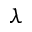<formula> <loc_0><loc_0><loc_500><loc_500>\lambda</formula> 